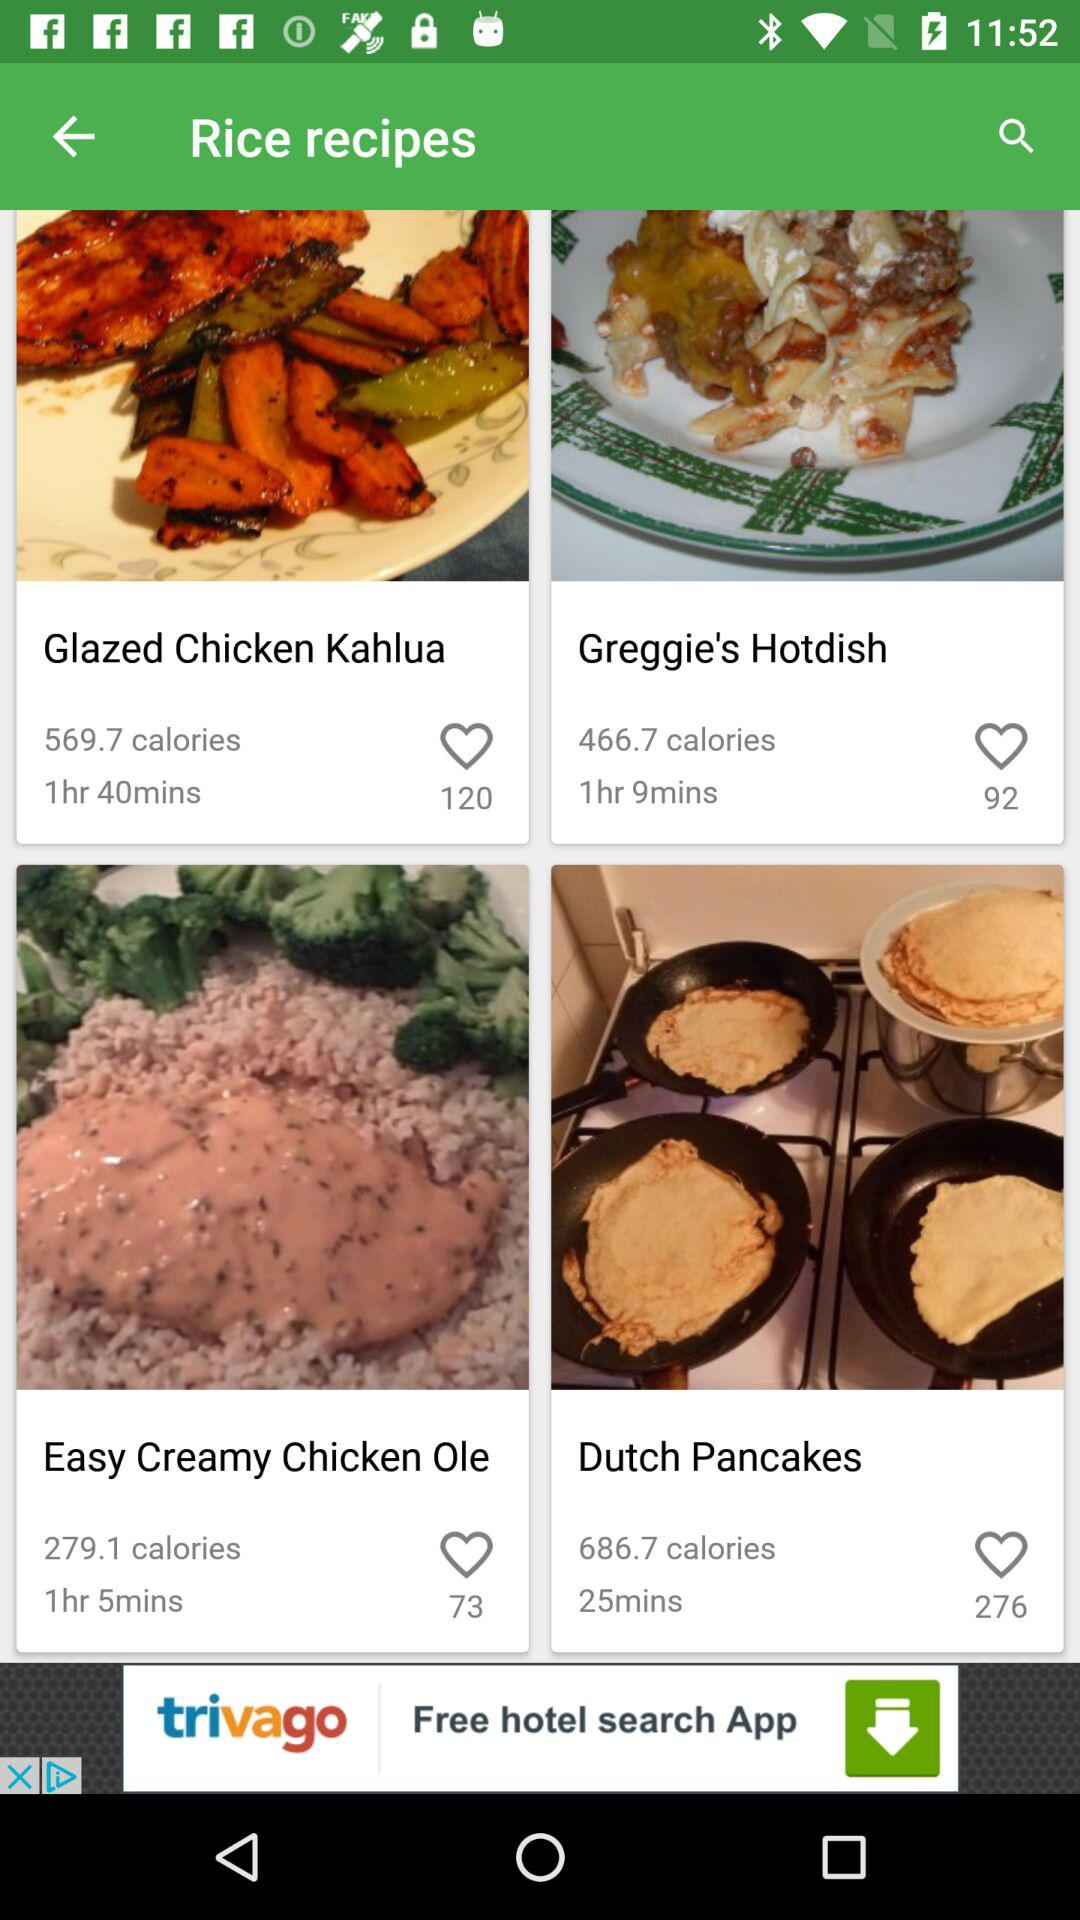How long does it take to make the "Dutch Pancakes"? It takes 25 minutes to make the "Dutch Pancakes". 